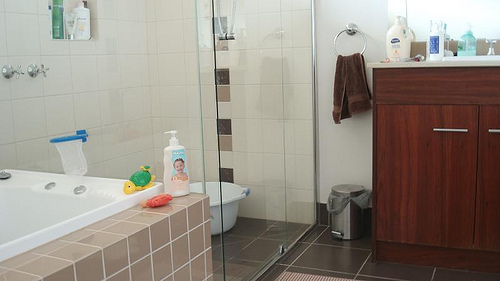Please provide a short description for this region: [0.45, 0.22, 0.48, 0.3]. A gleaming metal handle attached to the shower door. 